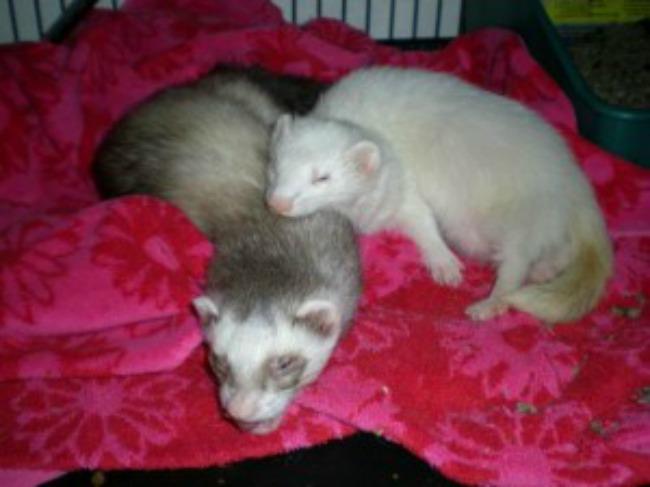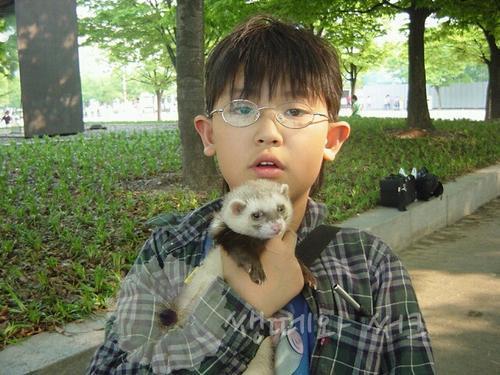The first image is the image on the left, the second image is the image on the right. Assess this claim about the two images: "The left image contains a ferret resting its head on another ferrets neck.". Correct or not? Answer yes or no. Yes. 